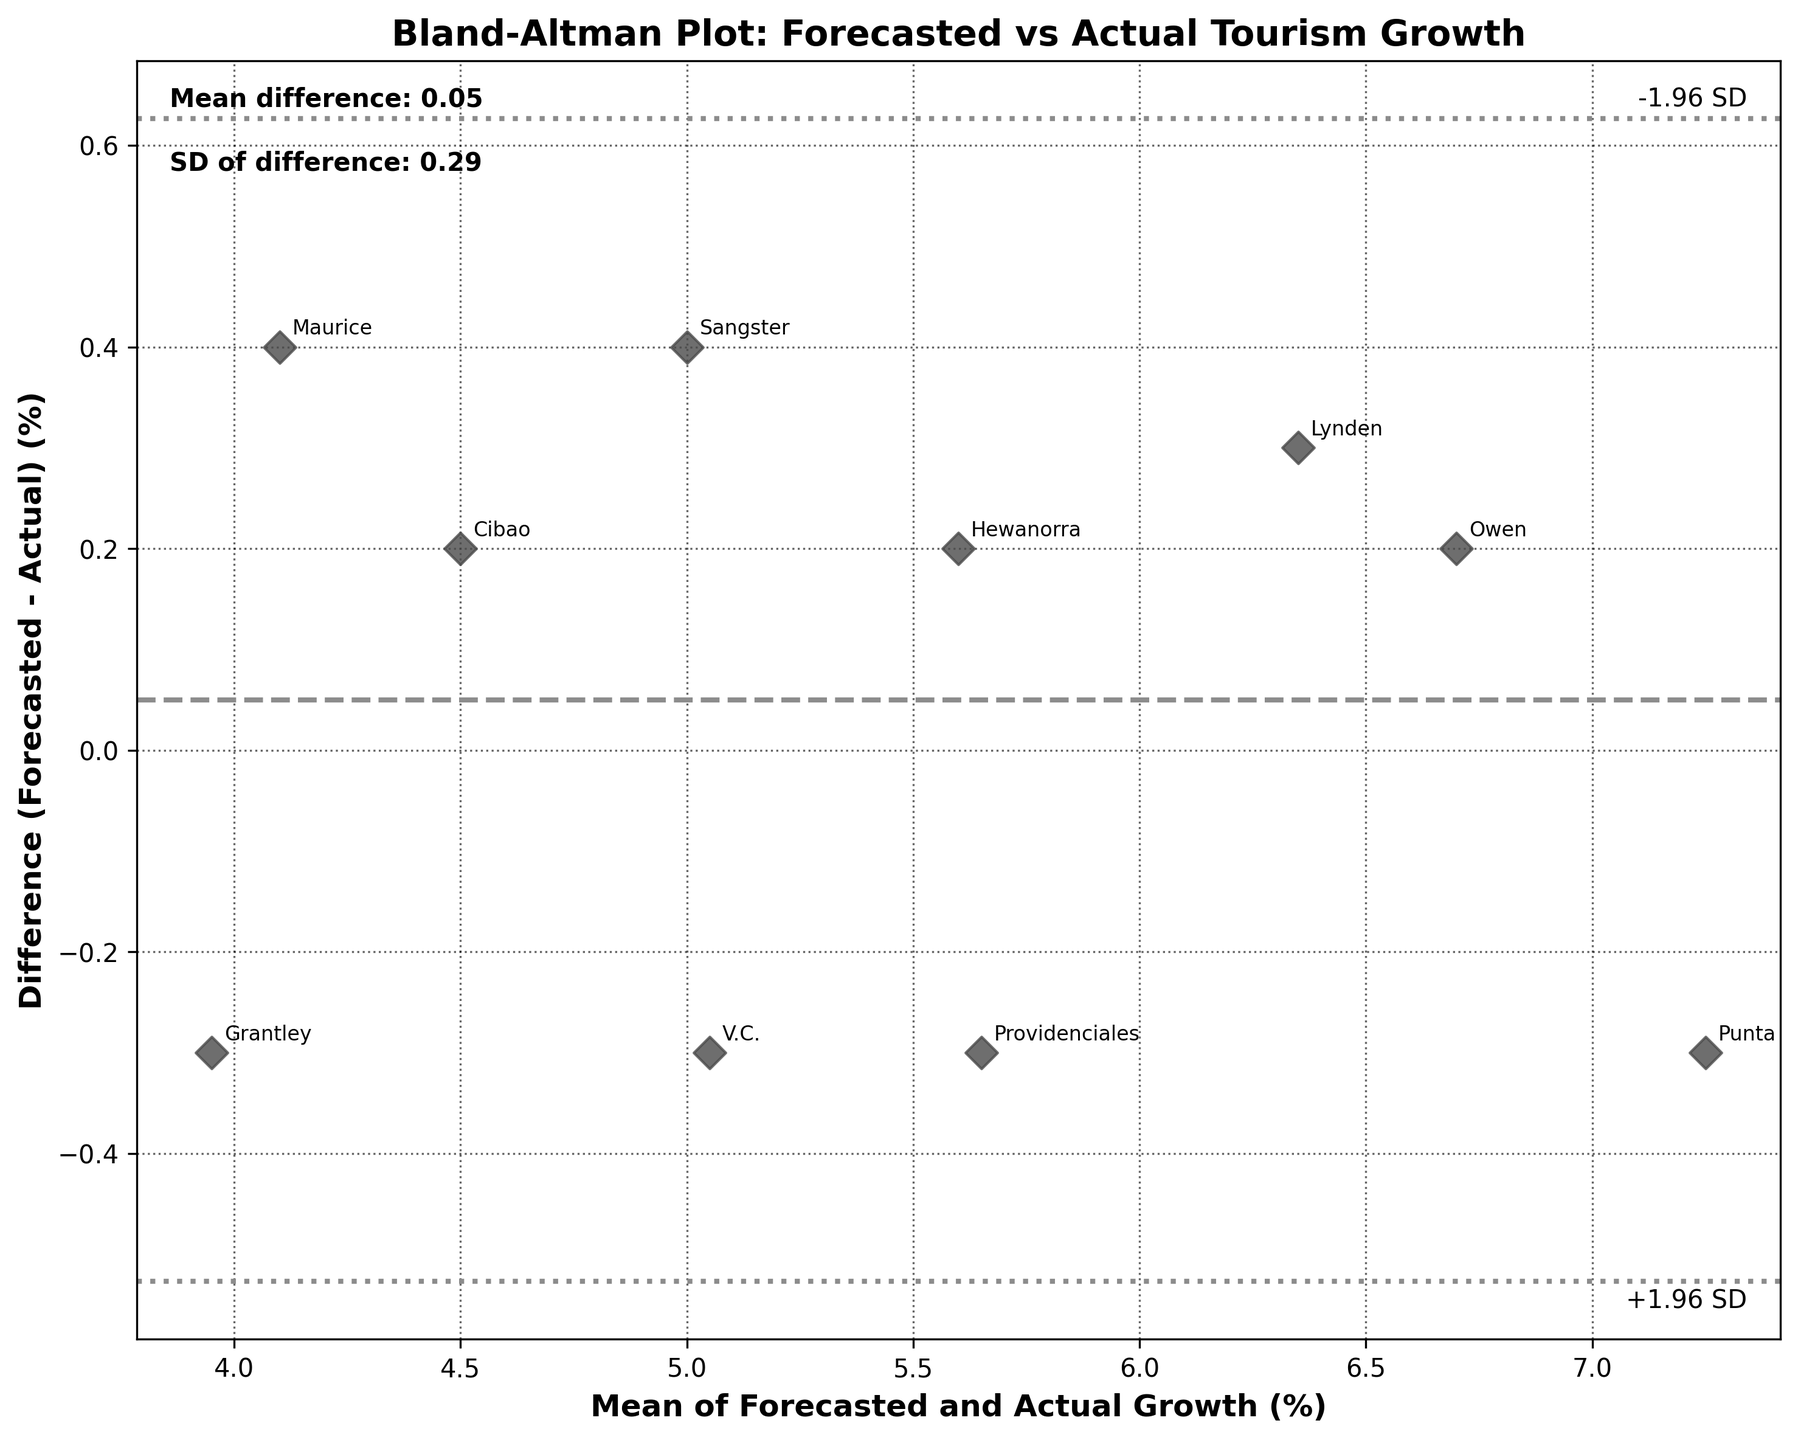What is the title of the plot? The title of the plot is displayed at the top-center of the figure, specifying what the graph represents.
Answer: Bland-Altman Plot: Forecasted vs Actual Tourism Growth How many data points are shown in the plot? Count the number of data points, which are depicted as scattered points within the figure.
Answer: 10 What is the mean difference between forecasted and actual growth? The plot includes textual information about the mean difference which is usually annotated on the plot.
Answer: 0.06 Which airport has the highest mean growth value? Identify the dot that is furthest to the right on the x-axis, and then check the annotation for the relevant airport name.
Answer: Punta Cana What is the overall pattern in the Bland–Altman plot? Observe the distribution of the data points and the relative position concerning the horizontal axis and lines representing the mean and standard deviation intervals.
Answer: Data points are fairly centered around the mean difference line Which airport showed the largest overestimation in forecasted growth? Find the data point that has the largest positive difference (forecasted - actual) by looking above the mean difference line.
Answer: Lynden Pindling Are there any airports where the forecasted growth exactly matches the actual growth? Examine if any data points are situated on the zero-difference (horizontal) line on the plot.
Answer: No What do the dotted lines on the plot represent? Refer to the plot description that annotates the lines, as they usually represent the limits of agreement (+/- 1.96 SD from the mean difference).
Answer: Limits of agreement Is the standard deviation of the differences higher or lower than 0.2? Check the annotated text inside the plot that mentions the standard deviation of differences.
Answer: Higher Which airport showed the largest underestimation in forecasted growth? Identify the data point with the largest negative difference (forecasted - actual) below the mean difference line.
Answer: Grantley Adams 